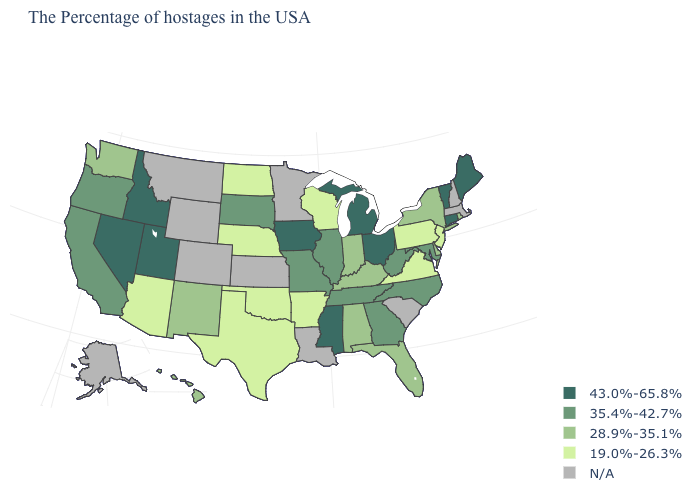Among the states that border Idaho , does Washington have the lowest value?
Answer briefly. Yes. What is the value of New Hampshire?
Answer briefly. N/A. Does the map have missing data?
Concise answer only. Yes. What is the value of Mississippi?
Give a very brief answer. 43.0%-65.8%. What is the lowest value in the USA?
Concise answer only. 19.0%-26.3%. Name the states that have a value in the range 43.0%-65.8%?
Write a very short answer. Maine, Vermont, Connecticut, Ohio, Michigan, Mississippi, Iowa, Utah, Idaho, Nevada. Name the states that have a value in the range 19.0%-26.3%?
Answer briefly. New Jersey, Pennsylvania, Virginia, Wisconsin, Arkansas, Nebraska, Oklahoma, Texas, North Dakota, Arizona. What is the highest value in states that border New Jersey?
Write a very short answer. 28.9%-35.1%. What is the value of Washington?
Quick response, please. 28.9%-35.1%. Does the first symbol in the legend represent the smallest category?
Be succinct. No. What is the highest value in states that border Kansas?
Write a very short answer. 35.4%-42.7%. Among the states that border Arkansas , does Missouri have the highest value?
Be succinct. No. What is the lowest value in the USA?
Concise answer only. 19.0%-26.3%. Does Michigan have the highest value in the MidWest?
Quick response, please. Yes. 